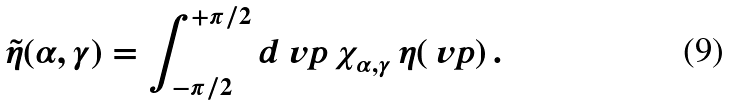<formula> <loc_0><loc_0><loc_500><loc_500>\tilde { \eta } ( \alpha , \gamma ) = \int _ { - \pi / 2 } ^ { + \pi / 2 } d \ v p \, \chi _ { \alpha , \gamma } \, \eta ( \ v p ) \, .</formula> 